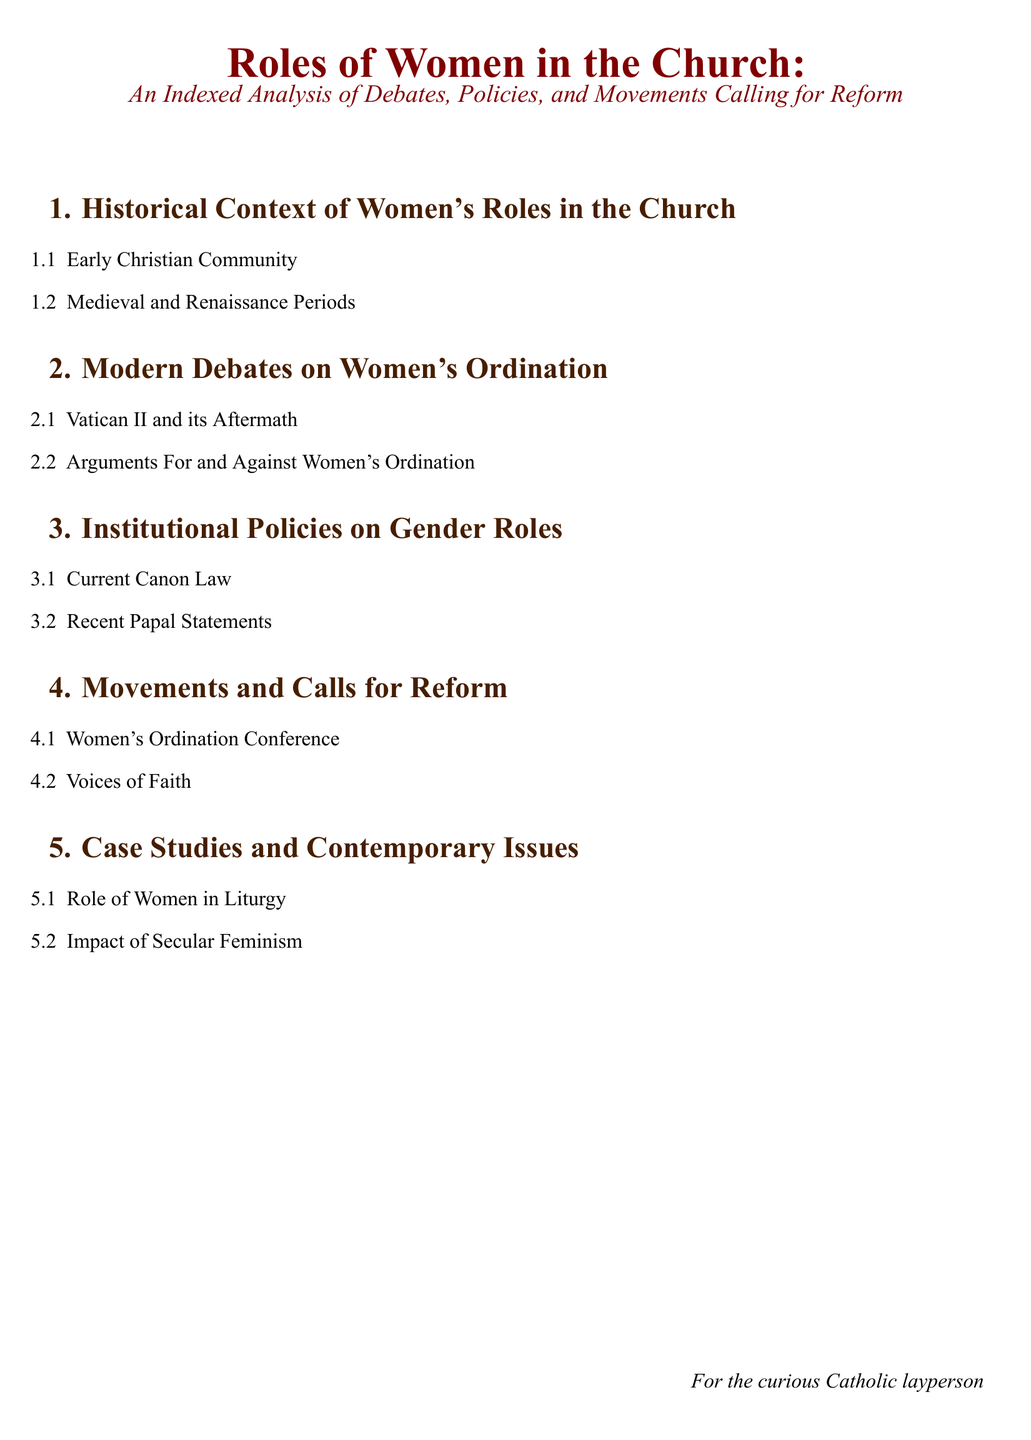What is the title of the document? The title provides an overview of the topic being addressed, which is "Roles of Women in the Church: An Indexed Analysis of Debates, Policies, and Movements Calling for Reform."
Answer: Roles of Women in the Church: An Indexed Analysis of Debates, Policies, and Movements Calling for Reform How many main sections are there in the document? The main sections are listed numerically at the beginning of the document, which shows there are five distinct sections.
Answer: 5 What is discussed in section 2.1? Section 2.1 addresses a key historical and theological moment that affected women's roles in the Church, specifically the outcomes following a significant council.
Answer: Vatican II and its Aftermath What movement is highlighted in section 4.1? Section 4.1 points to a specific group advocating for a change regarding women's roles within ecclesiastical structures.
Answer: Women's Ordination Conference What is one contemporary issue discussed in section 5? Section 5 indicates current challenges and discussions regarding the role of women within the Church, specifically societal influences.
Answer: Impact of Secular Feminism 